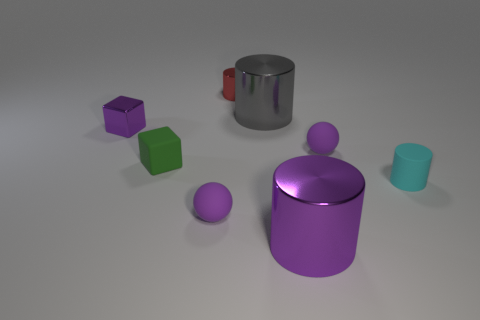Subtract 1 cylinders. How many cylinders are left? 3 Add 2 green cubes. How many objects exist? 10 Subtract all cubes. How many objects are left? 6 Add 5 small blue blocks. How many small blue blocks exist? 5 Subtract 0 green balls. How many objects are left? 8 Subtract all metal things. Subtract all big gray metal spheres. How many objects are left? 4 Add 1 small green blocks. How many small green blocks are left? 2 